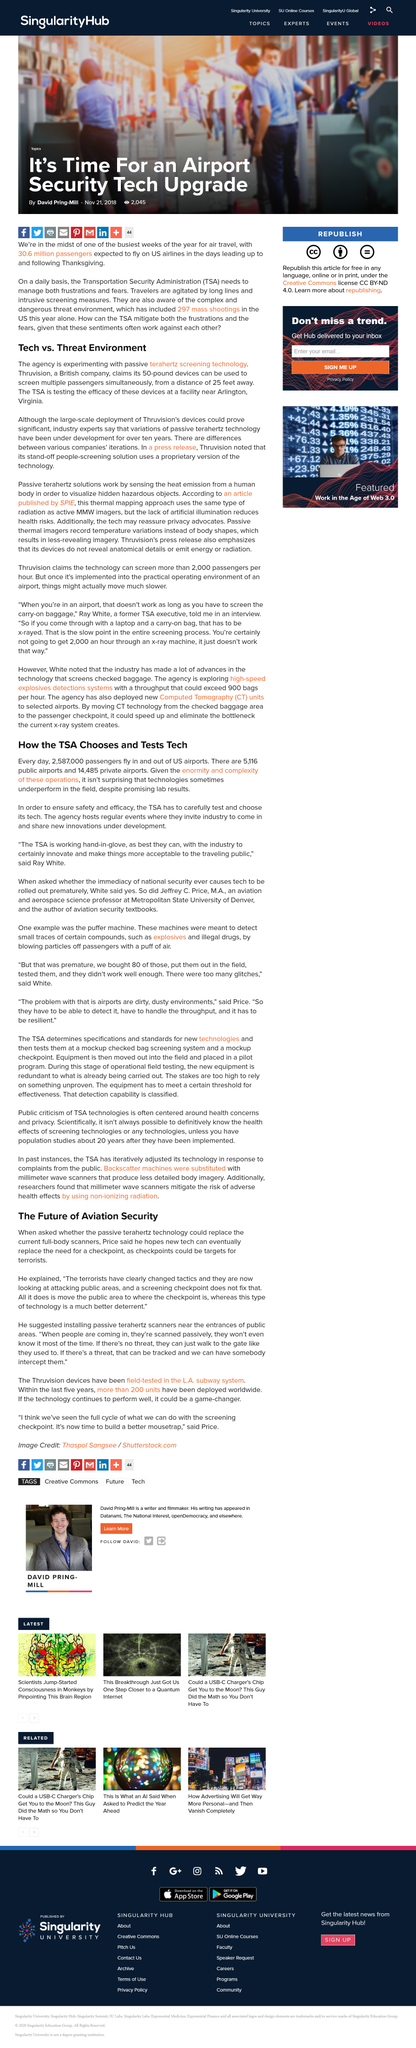List a handful of essential elements in this visual. The Transportation Security Administration (TSA) requires an upgrade in airport security due to the significant increase in the number of passengers traveling on US airlines. New terrorist tactics involve targeting public areas. There have been 297 mass shootings in the United States so far this year. According to estimates, US airlines are expected to serve 30.6 million passengers in the days leading up to and following Thanksgiving. The new technology aims to replace the need for checkpoints by making them less susceptible to terrorist attacks. 